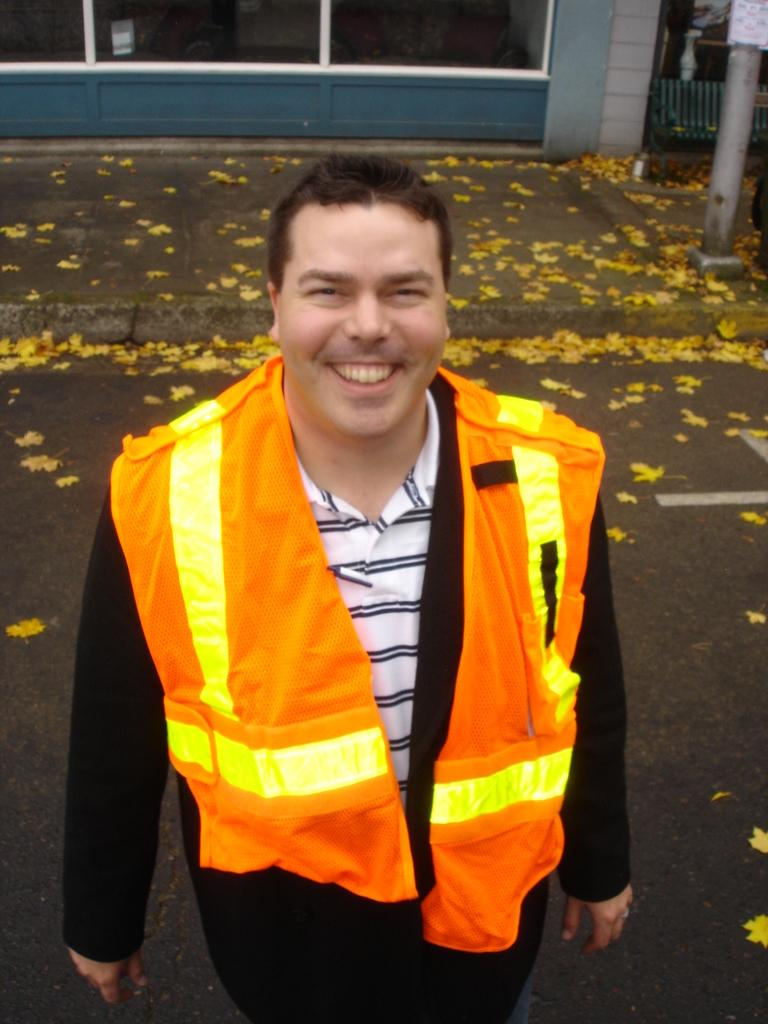What is the person in the image wearing? The person in the image is wearing a jacket. What can be seen on the ground in the image? There are leaves on the ground in the image. What is visible in the background of the image? There is a pole and a building in the background of the image. What type of current is flowing through the person's legs in the image? There is no current flowing through the person's legs in the image, as they are not depicted as being in water or any other conductive medium. 